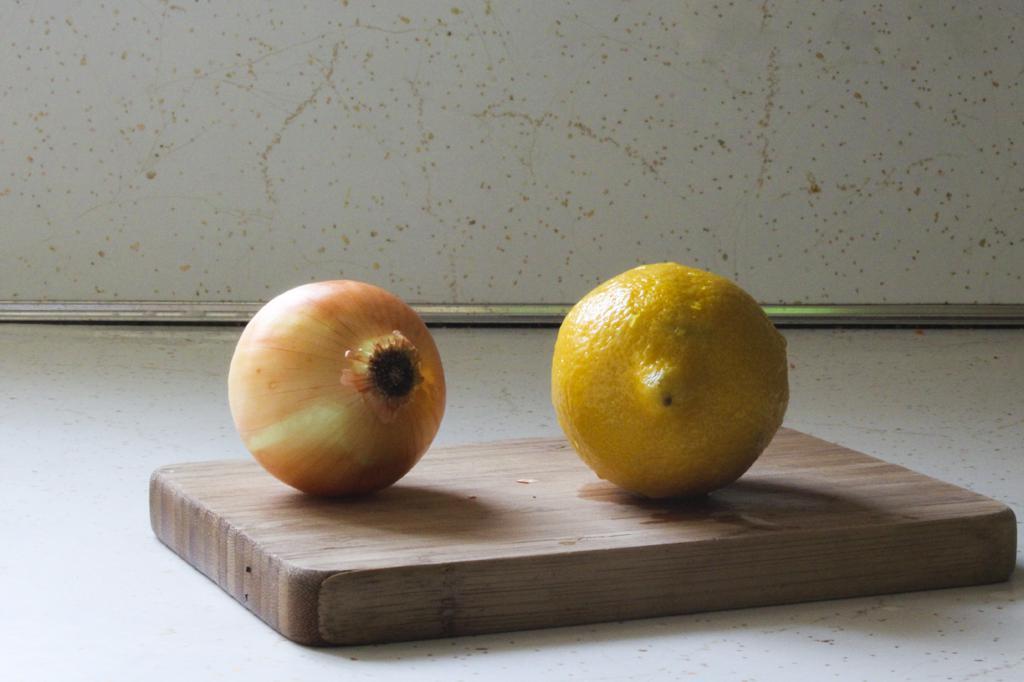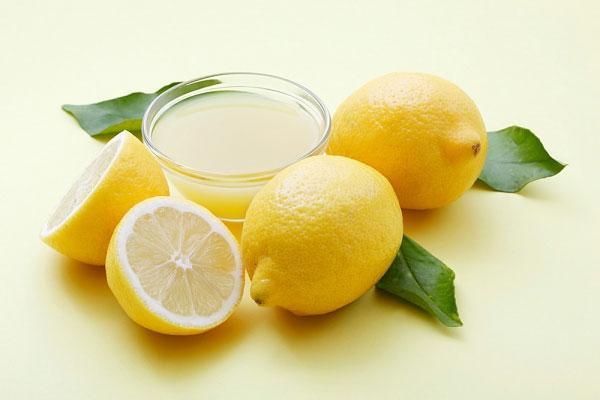The first image is the image on the left, the second image is the image on the right. For the images displayed, is the sentence "An image includes a whole onion and a half lemon, but not a whole lemon or a half onion." factually correct? Answer yes or no. No. The first image is the image on the left, the second image is the image on the right. For the images displayed, is the sentence "In one of the images there is a whole lemon next to a whole onion." factually correct? Answer yes or no. Yes. 